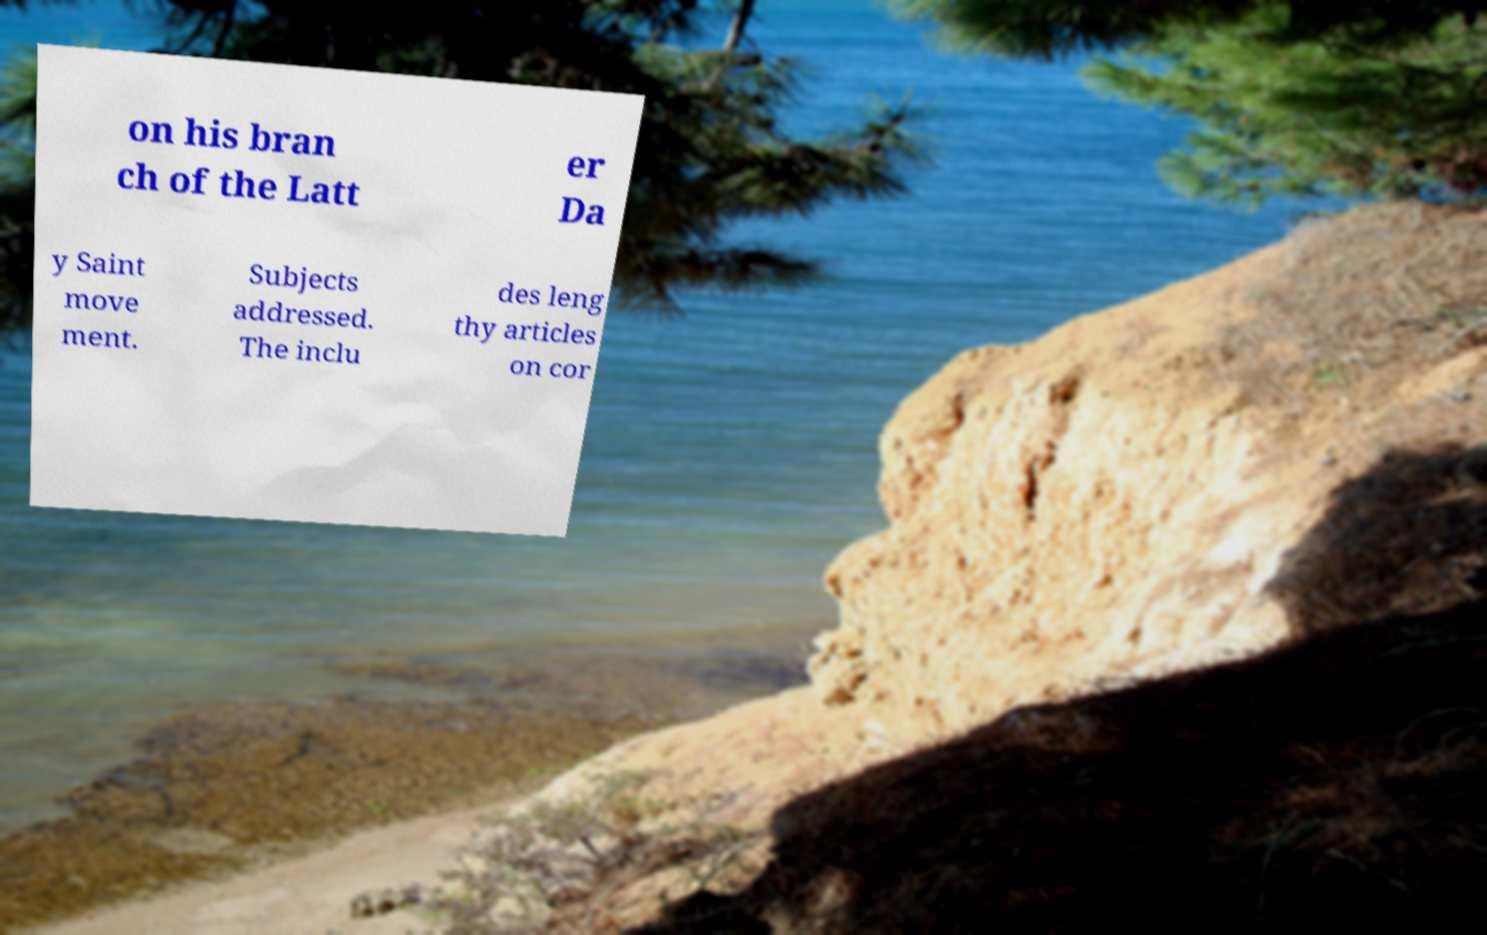Could you assist in decoding the text presented in this image and type it out clearly? on his bran ch of the Latt er Da y Saint move ment. Subjects addressed. The inclu des leng thy articles on cor 